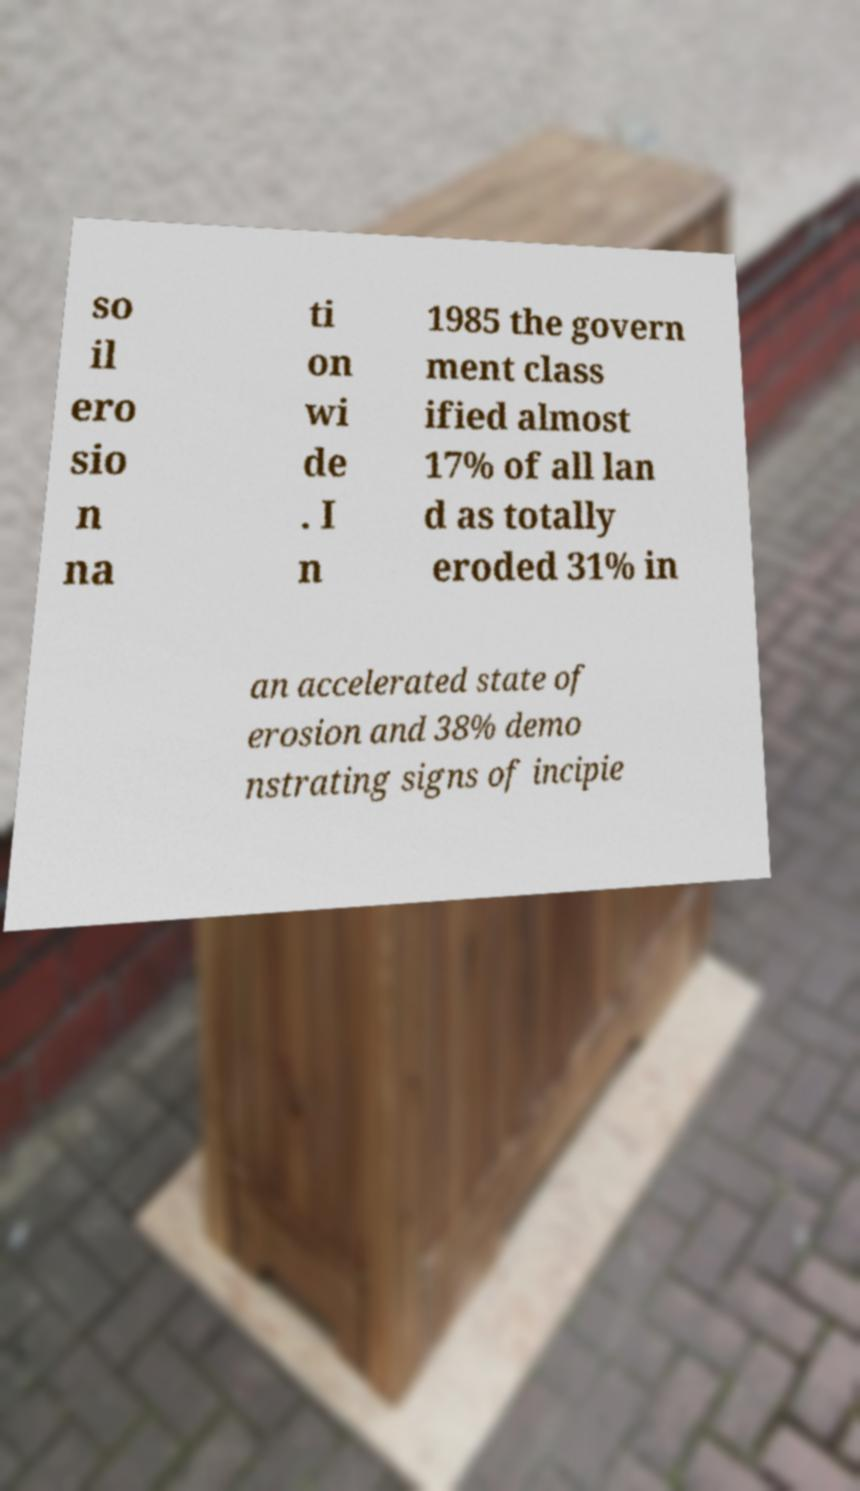Can you accurately transcribe the text from the provided image for me? so il ero sio n na ti on wi de . I n 1985 the govern ment class ified almost 17% of all lan d as totally eroded 31% in an accelerated state of erosion and 38% demo nstrating signs of incipie 